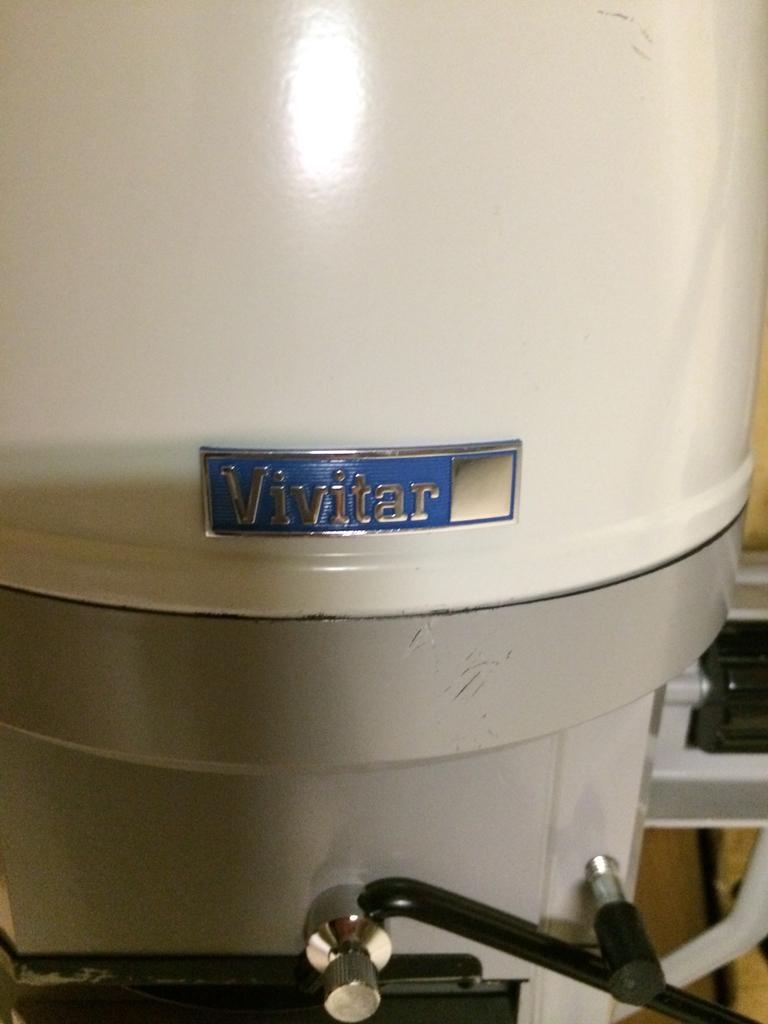<image>
Summarize the visual content of the image. the name Vivitar is on the white object 